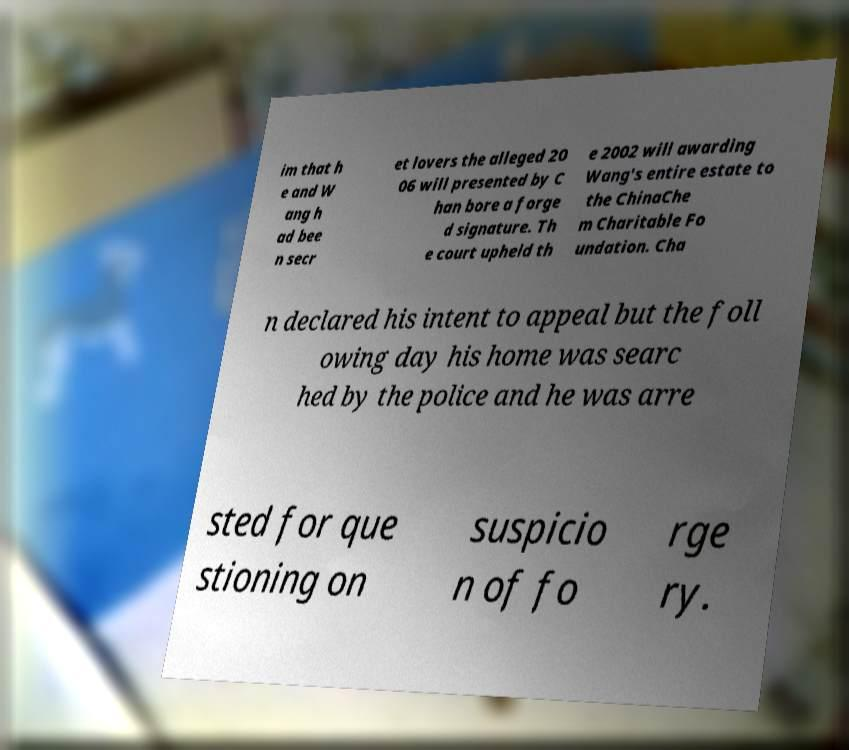Please identify and transcribe the text found in this image. im that h e and W ang h ad bee n secr et lovers the alleged 20 06 will presented by C han bore a forge d signature. Th e court upheld th e 2002 will awarding Wang's entire estate to the ChinaChe m Charitable Fo undation. Cha n declared his intent to appeal but the foll owing day his home was searc hed by the police and he was arre sted for que stioning on suspicio n of fo rge ry. 